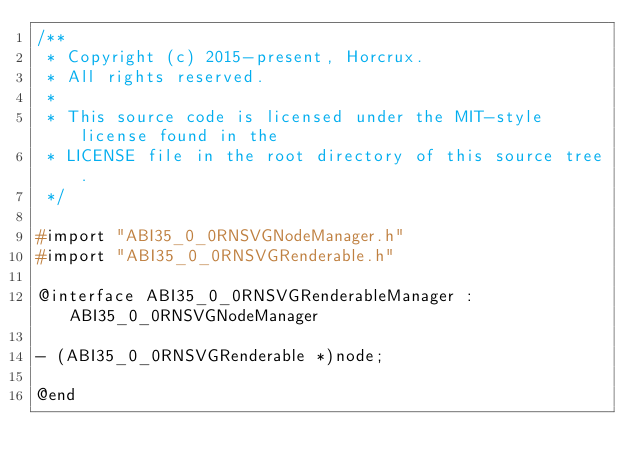Convert code to text. <code><loc_0><loc_0><loc_500><loc_500><_C_>/**
 * Copyright (c) 2015-present, Horcrux.
 * All rights reserved.
 *
 * This source code is licensed under the MIT-style license found in the
 * LICENSE file in the root directory of this source tree.
 */

#import "ABI35_0_0RNSVGNodeManager.h"
#import "ABI35_0_0RNSVGRenderable.h"

@interface ABI35_0_0RNSVGRenderableManager : ABI35_0_0RNSVGNodeManager

- (ABI35_0_0RNSVGRenderable *)node;

@end
</code> 